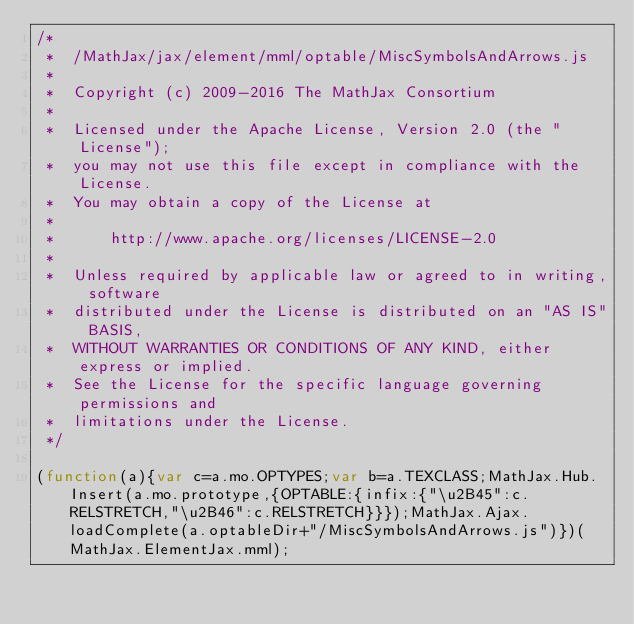Convert code to text. <code><loc_0><loc_0><loc_500><loc_500><_JavaScript_>/*
 *  /MathJax/jax/element/mml/optable/MiscSymbolsAndArrows.js
 *
 *  Copyright (c) 2009-2016 The MathJax Consortium
 *
 *  Licensed under the Apache License, Version 2.0 (the "License");
 *  you may not use this file except in compliance with the License.
 *  You may obtain a copy of the License at
 *
 *      http://www.apache.org/licenses/LICENSE-2.0
 *
 *  Unless required by applicable law or agreed to in writing, software
 *  distributed under the License is distributed on an "AS IS" BASIS,
 *  WITHOUT WARRANTIES OR CONDITIONS OF ANY KIND, either express or implied.
 *  See the License for the specific language governing permissions and
 *  limitations under the License.
 */

(function(a){var c=a.mo.OPTYPES;var b=a.TEXCLASS;MathJax.Hub.Insert(a.mo.prototype,{OPTABLE:{infix:{"\u2B45":c.RELSTRETCH,"\u2B46":c.RELSTRETCH}}});MathJax.Ajax.loadComplete(a.optableDir+"/MiscSymbolsAndArrows.js")})(MathJax.ElementJax.mml);
</code> 